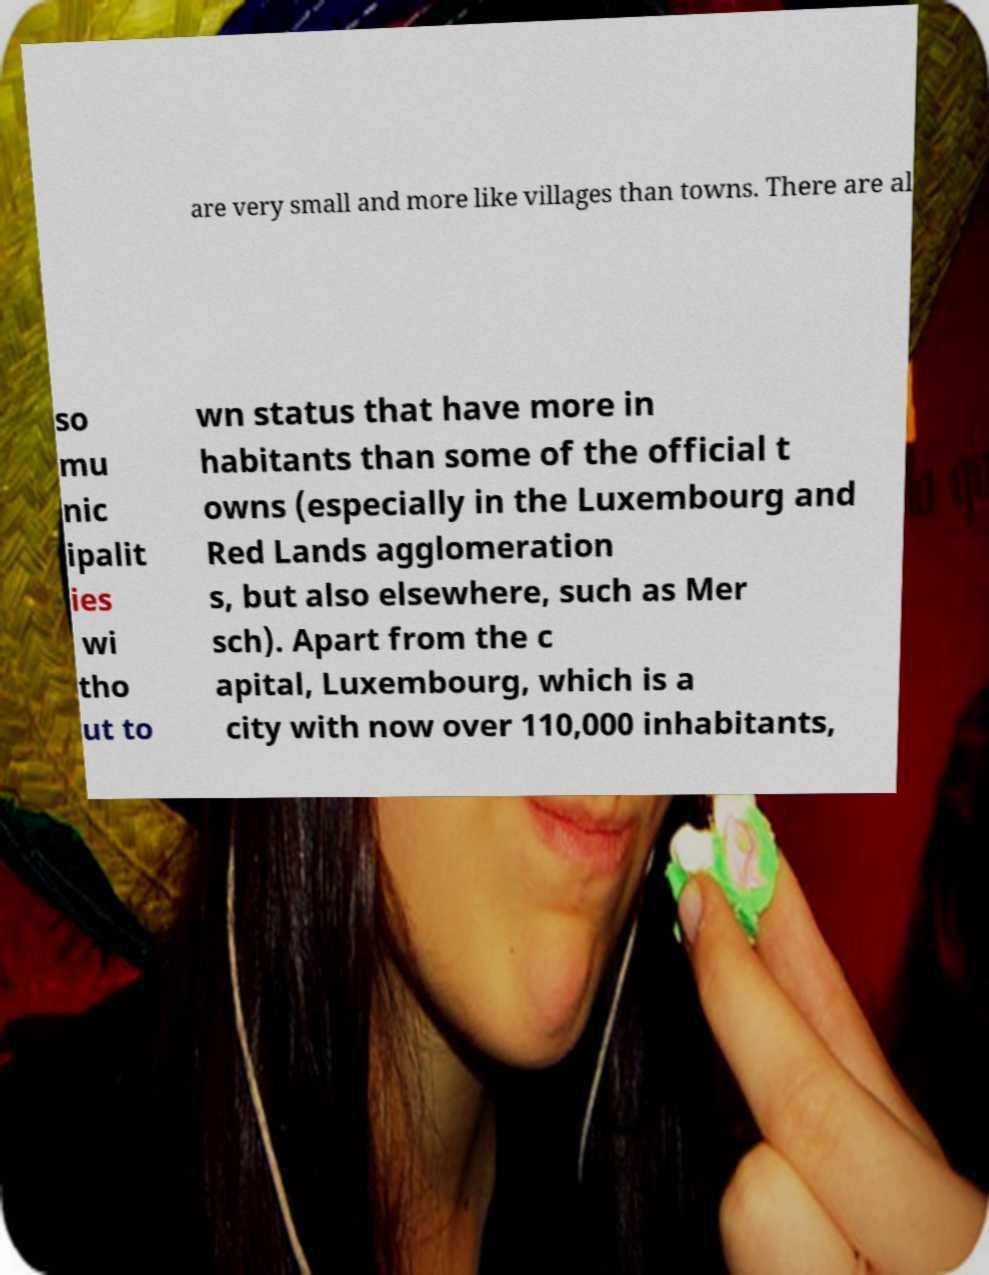I need the written content from this picture converted into text. Can you do that? are very small and more like villages than towns. There are al so mu nic ipalit ies wi tho ut to wn status that have more in habitants than some of the official t owns (especially in the Luxembourg and Red Lands agglomeration s, but also elsewhere, such as Mer sch). Apart from the c apital, Luxembourg, which is a city with now over 110,000 inhabitants, 